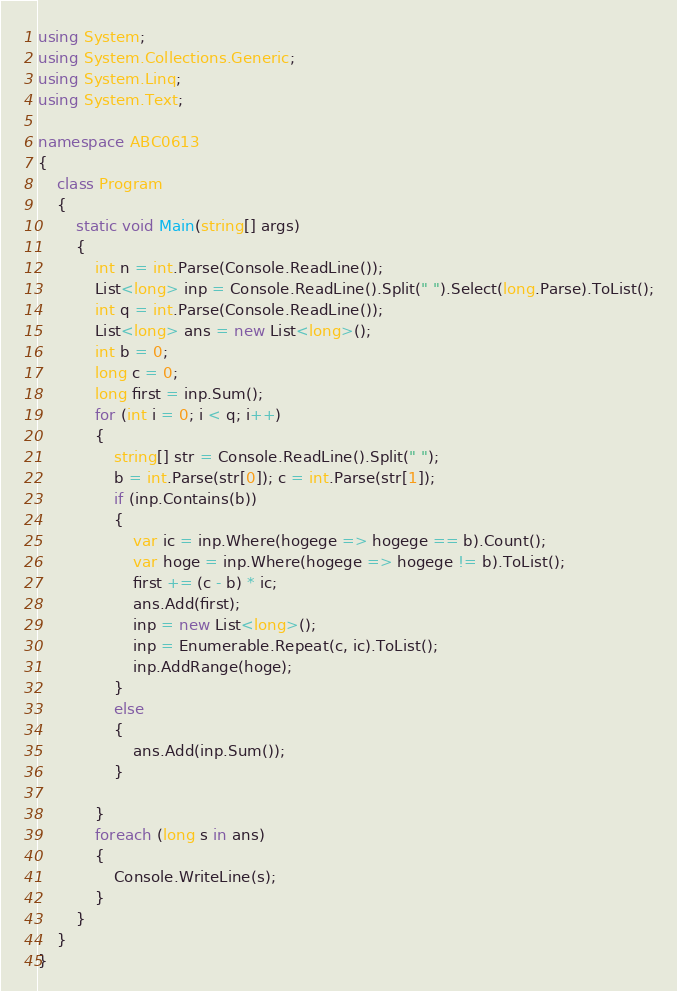<code> <loc_0><loc_0><loc_500><loc_500><_C#_>using System;
using System.Collections.Generic;
using System.Linq;
using System.Text;

namespace ABC0613
{
    class Program
    {
        static void Main(string[] args)
        {
            int n = int.Parse(Console.ReadLine());
            List<long> inp = Console.ReadLine().Split(" ").Select(long.Parse).ToList();
            int q = int.Parse(Console.ReadLine());
            List<long> ans = new List<long>();
            int b = 0;
            long c = 0;
            long first = inp.Sum();
            for (int i = 0; i < q; i++)
            {
                string[] str = Console.ReadLine().Split(" ");
                b = int.Parse(str[0]); c = int.Parse(str[1]);
                if (inp.Contains(b))
                {
                    var ic = inp.Where(hogege => hogege == b).Count();
                    var hoge = inp.Where(hogege => hogege != b).ToList();
                    first += (c - b) * ic;
                    ans.Add(first);
                    inp = new List<long>();
                    inp = Enumerable.Repeat(c, ic).ToList();
                    inp.AddRange(hoge);
                }
                else
                {
                    ans.Add(inp.Sum());
                }
                
            }
            foreach (long s in ans)
            {
                Console.WriteLine(s);
            }
        }
    }
}
</code> 